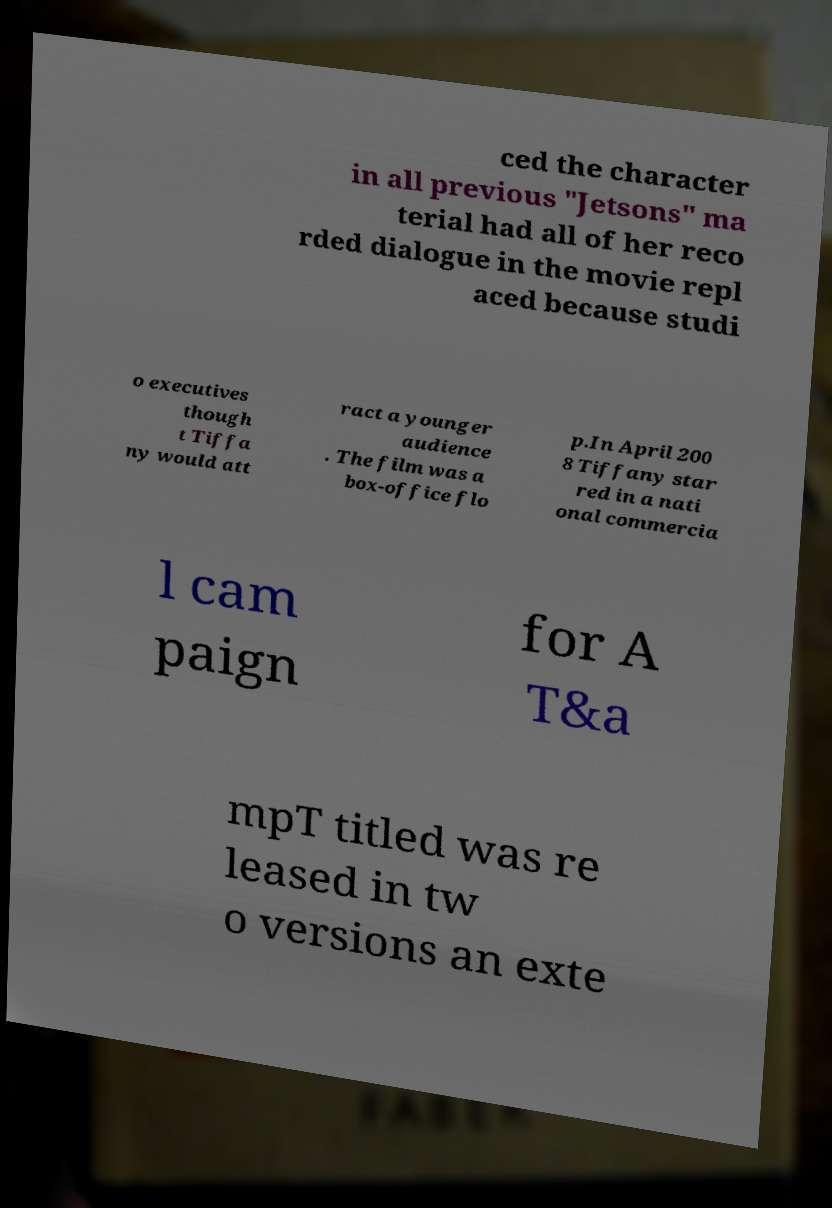What messages or text are displayed in this image? I need them in a readable, typed format. ced the character in all previous "Jetsons" ma terial had all of her reco rded dialogue in the movie repl aced because studi o executives though t Tiffa ny would att ract a younger audience . The film was a box-office flo p.In April 200 8 Tiffany star red in a nati onal commercia l cam paign for A T&a mpT titled was re leased in tw o versions an exte 